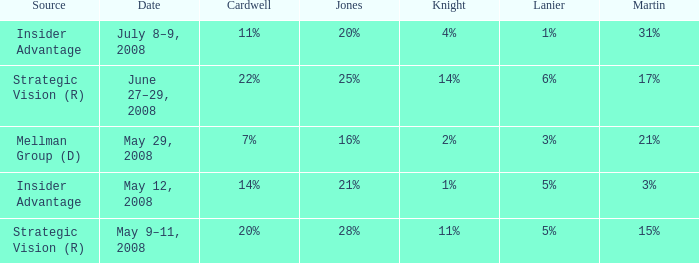What Lanier has a Cardwell of 20%? 5%. 